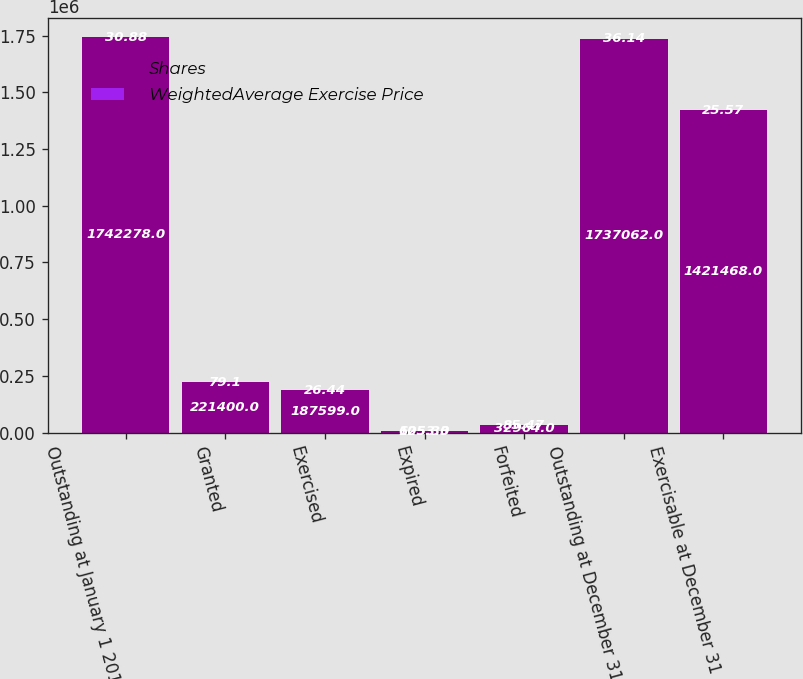Convert chart to OTSL. <chart><loc_0><loc_0><loc_500><loc_500><stacked_bar_chart><ecel><fcel>Outstanding at January 1 2010<fcel>Granted<fcel>Exercised<fcel>Expired<fcel>Forfeited<fcel>Outstanding at December 31<fcel>Exercisable at December 31<nl><fcel>Shares<fcel>1.74228e+06<fcel>221400<fcel>187599<fcel>6053<fcel>32964<fcel>1.73706e+06<fcel>1.42147e+06<nl><fcel>WeightedAverage Exercise Price<fcel>30.88<fcel>79.1<fcel>26.44<fcel>125.33<fcel>85.47<fcel>36.14<fcel>25.57<nl></chart> 